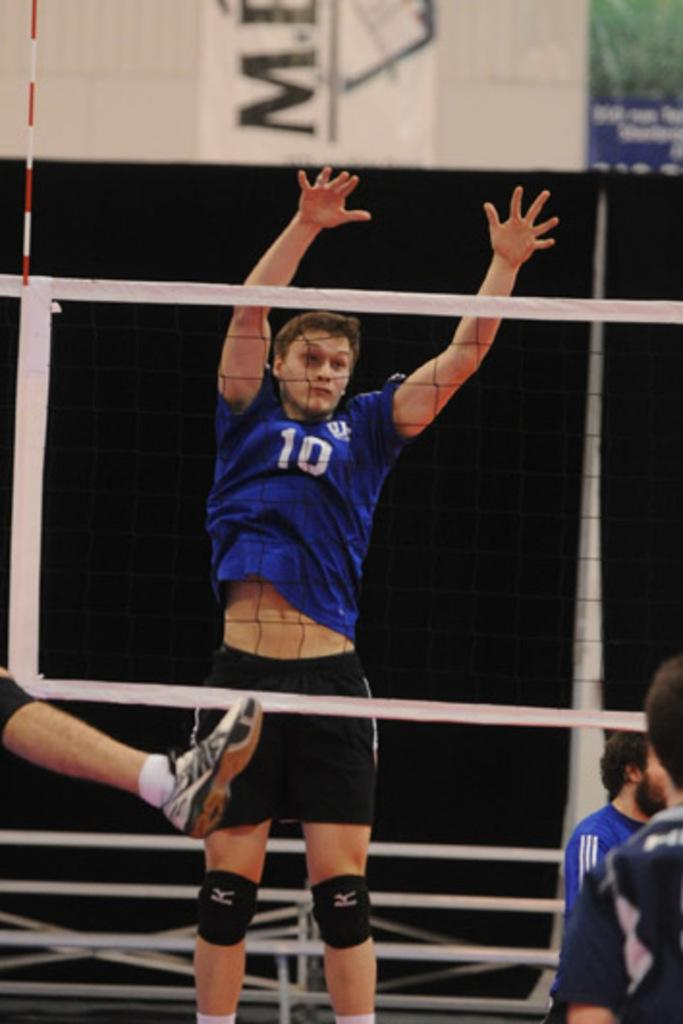<image>
Give a short and clear explanation of the subsequent image. Some men are playing volley ball and a player in a blue shirt with the number 10 on it is jumping. 